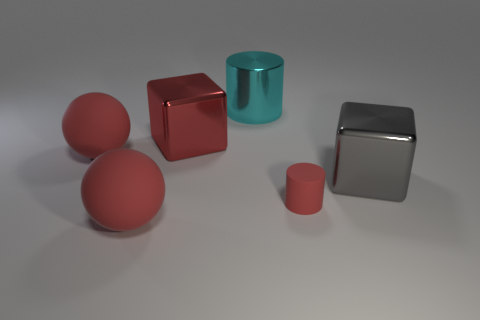Subtract all red spheres. How many were subtracted if there are1red spheres left? 1 Add 1 gray cubes. How many objects exist? 7 Subtract all cylinders. How many objects are left? 4 Subtract 2 red balls. How many objects are left? 4 Subtract all large green rubber things. Subtract all big blocks. How many objects are left? 4 Add 4 tiny rubber cylinders. How many tiny rubber cylinders are left? 5 Add 1 red metallic objects. How many red metallic objects exist? 2 